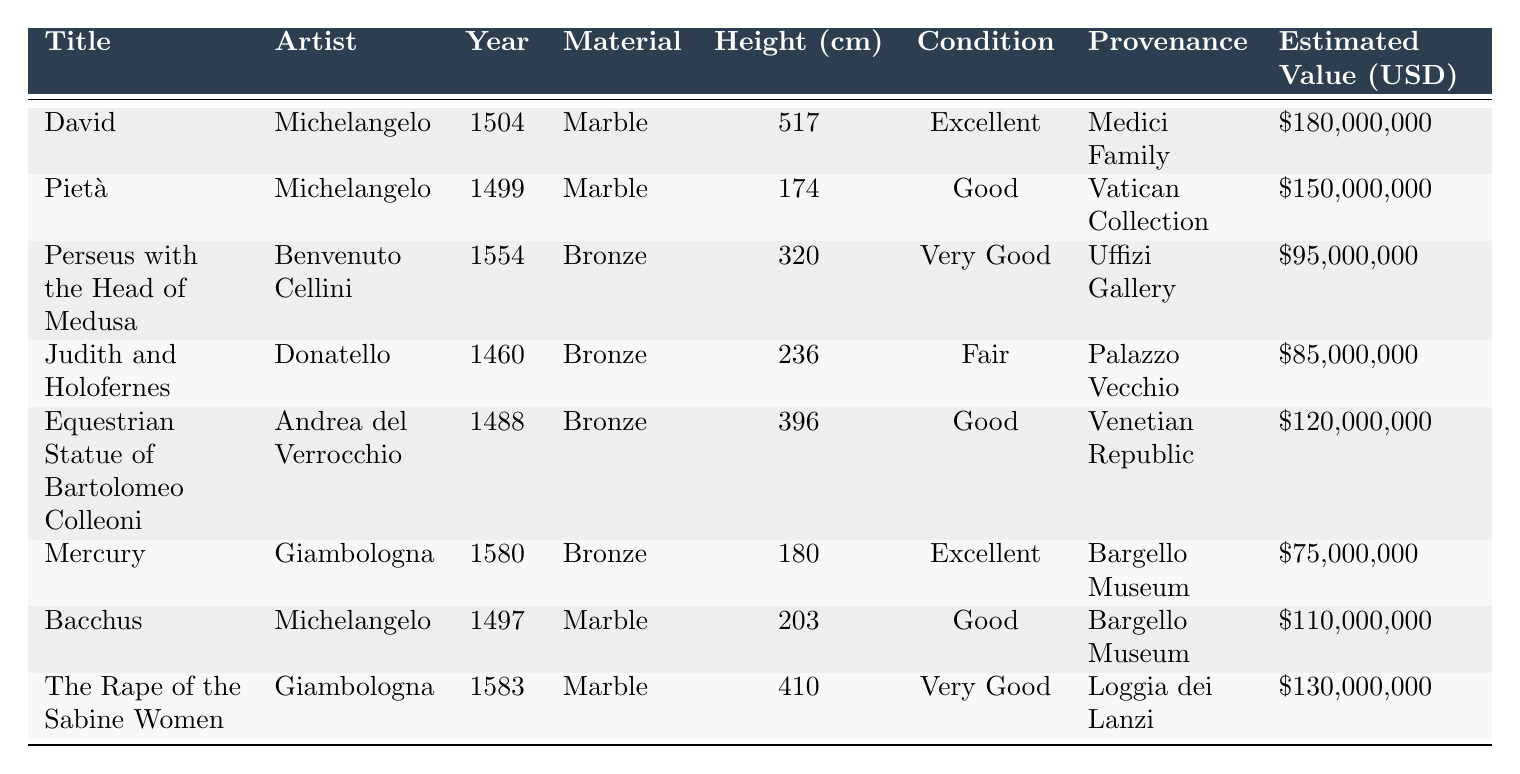What is the estimated value of the sculpture "David"? The estimated value is listed in the "Estimated Value (USD)" column for the sculpture "David." It states $180,000,000.
Answer: $180,000,000 Who is the artist of "Pietà"? The artist's name is found in the "Artist" column for the sculpture titled "Pietà," which shows that it is Michelangelo.
Answer: Michelangelo What material is "Perseus with the Head of Medusa" made of? The material for "Perseus with the Head of Medusa" is indicated in the "Material" column, which specifies it is made of bronze.
Answer: Bronze Which sculpture has the largest height? To find the largest height, compare the "Height (cm)" values across all sculptures; "David" at 517 cm is the tallest.
Answer: David What is the average estimated value of sculptures made from marble? The total estimated values for marble sculptures (David, Pietà, Bacchus, Rape of the Sabine Women) are $180,000,000 + $150,000,000 + $110,000,000 + $130,000,000 = $570,000,000. There are 4 sculptures, so the average is $570,000,000 / 4 = $142,500,000.
Answer: $142,500,000 Is the sculptor of "Equestrian Statue of Bartolomeo Colleoni" the same as "Judith and Holofernes"? The artist for "Equestrian Statue of Bartolomeo Colleoni" is Andrea del Verrocchio, while "Judith and Holofernes" is by Donatello; thus, they are different artists.
Answer: No Which sculpture has the best condition? The condition is specified in the "Condition" column; "David" and "Mercury" are listed as "Excellent," which is the best condition among the sculptures.
Answer: David and Mercury What is the total estimated value of all sculptures in the collection? Summing the estimated values from the "Estimated Value (USD)" column: $180,000,000 + $150,000,000 + $95,000,000 + $85,000,000 + $120,000,000 + $75,000,000 + $110,000,000 + $130,000,000 = $1,045,000,000.
Answer: $1,045,000,000 How many sculptures are made of bronze? From the table, "Perseus with the Head of Medusa," "Judith and Holofernes," "Equestrian Statue of Bartolomeo Colleoni," "Mercury," and "Bacchus" are made of bronze, totaling 5 sculptures.
Answer: 5 